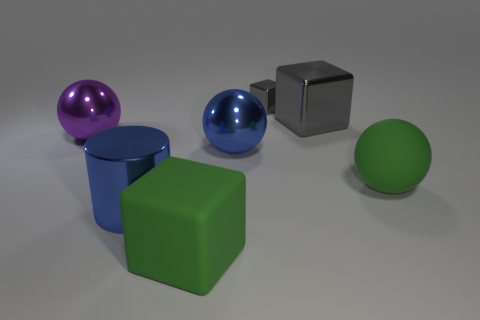Is there a metallic object that has the same size as the cylinder?
Keep it short and to the point. Yes. Are there the same number of big blue metallic cylinders in front of the metallic cylinder and tiny purple matte cubes?
Give a very brief answer. Yes. How many gray metal things are left of the large shiny object behind the purple sphere?
Your response must be concise. 1. There is a metal object that is both on the left side of the rubber block and right of the big purple shiny sphere; what shape is it?
Your answer should be very brief. Cylinder. What number of large blocks have the same color as the rubber sphere?
Give a very brief answer. 1. Is there a big blue cylinder right of the large purple thing in front of the large metal thing that is to the right of the blue sphere?
Provide a short and direct response. Yes. What size is the shiny thing that is to the left of the big metallic cube and on the right side of the blue metallic ball?
Your response must be concise. Small. What number of gray things have the same material as the large purple thing?
Your answer should be compact. 2. How many blocks are either matte things or big blue things?
Offer a terse response. 1. There is a gray cube behind the big cube that is behind the large blue thing that is behind the blue metal cylinder; what is its size?
Offer a very short reply. Small. 